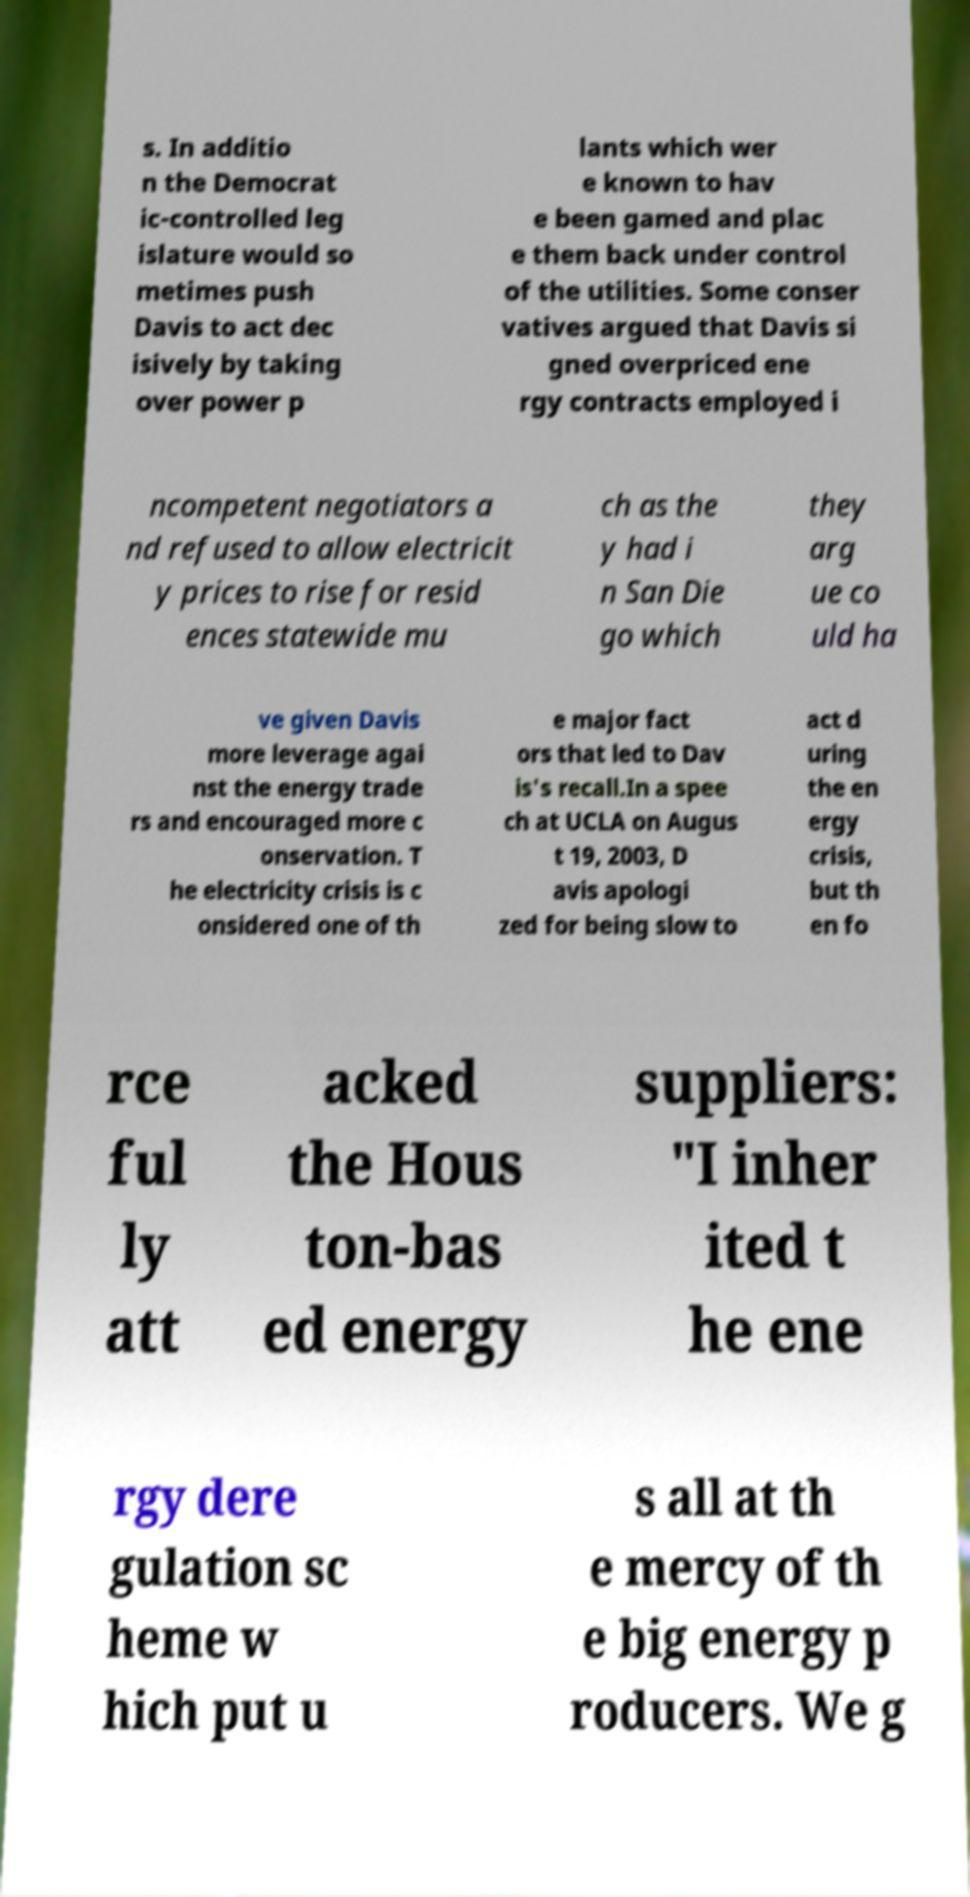Can you read and provide the text displayed in the image?This photo seems to have some interesting text. Can you extract and type it out for me? s. In additio n the Democrat ic-controlled leg islature would so metimes push Davis to act dec isively by taking over power p lants which wer e known to hav e been gamed and plac e them back under control of the utilities. Some conser vatives argued that Davis si gned overpriced ene rgy contracts employed i ncompetent negotiators a nd refused to allow electricit y prices to rise for resid ences statewide mu ch as the y had i n San Die go which they arg ue co uld ha ve given Davis more leverage agai nst the energy trade rs and encouraged more c onservation. T he electricity crisis is c onsidered one of th e major fact ors that led to Dav is's recall.In a spee ch at UCLA on Augus t 19, 2003, D avis apologi zed for being slow to act d uring the en ergy crisis, but th en fo rce ful ly att acked the Hous ton-bas ed energy suppliers: "I inher ited t he ene rgy dere gulation sc heme w hich put u s all at th e mercy of th e big energy p roducers. We g 